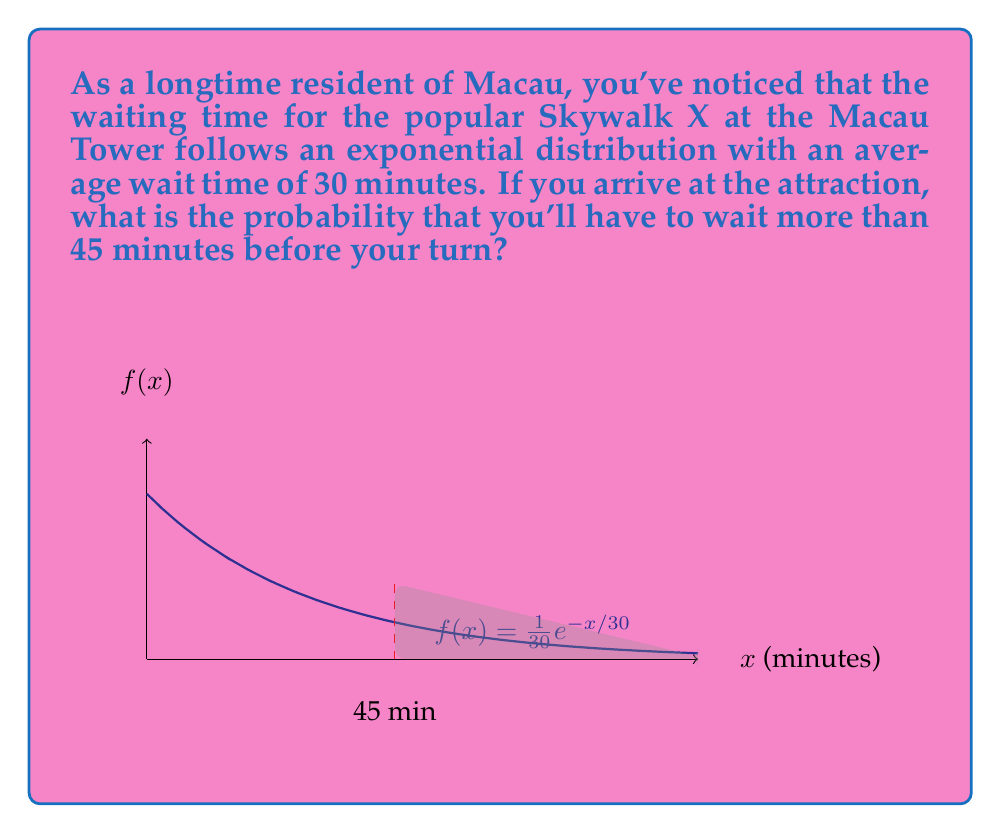Give your solution to this math problem. Let's approach this step-by-step:

1) The exponential distribution has the probability density function:

   $$f(x) = \lambda e^{-\lambda x}$$

   where $\lambda$ is the rate parameter.

2) Given that the average wait time is 30 minutes, we can determine $\lambda$:

   $$\frac{1}{\lambda} = 30$$
   $$\lambda = \frac{1}{30}$$

3) We want to find the probability of waiting more than 45 minutes, which is equivalent to:

   $$P(X > 45) = 1 - P(X \leq 45)$$

4) For the exponential distribution, the cumulative distribution function is:

   $$F(x) = 1 - e^{-\lambda x}$$

5) Therefore:

   $$P(X > 45) = 1 - (1 - e^{-\lambda 45})$$
               $$= e^{-\lambda 45}$$

6) Substituting $\lambda = \frac{1}{30}$:

   $$P(X > 45) = e^{-45/30}$$
               $$= e^{-1.5}$$

7) Calculating this value:

   $$P(X > 45) \approx 0.2231$$

Thus, the probability of waiting more than 45 minutes is approximately 0.2231 or 22.31%.
Answer: $e^{-1.5} \approx 0.2231$ 